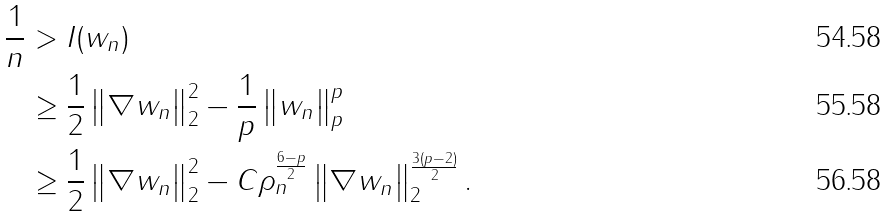<formula> <loc_0><loc_0><loc_500><loc_500>\frac { 1 } { n } & > I ( w _ { n } ) \\ & \geq \frac { 1 } { 2 } \left \| \nabla w _ { n } \right \| _ { 2 } ^ { 2 } - \frac { 1 } { p } \left \| w _ { n } \right \| _ { p } ^ { p } \\ & \geq \frac { 1 } { 2 } \left \| \nabla w _ { n } \right \| _ { 2 } ^ { 2 } - C \rho _ { n } ^ { \frac { 6 - p } { 2 } } \left \| \nabla w _ { n } \right \| _ { 2 } ^ { \frac { 3 ( p - 2 ) } { 2 } } .</formula> 